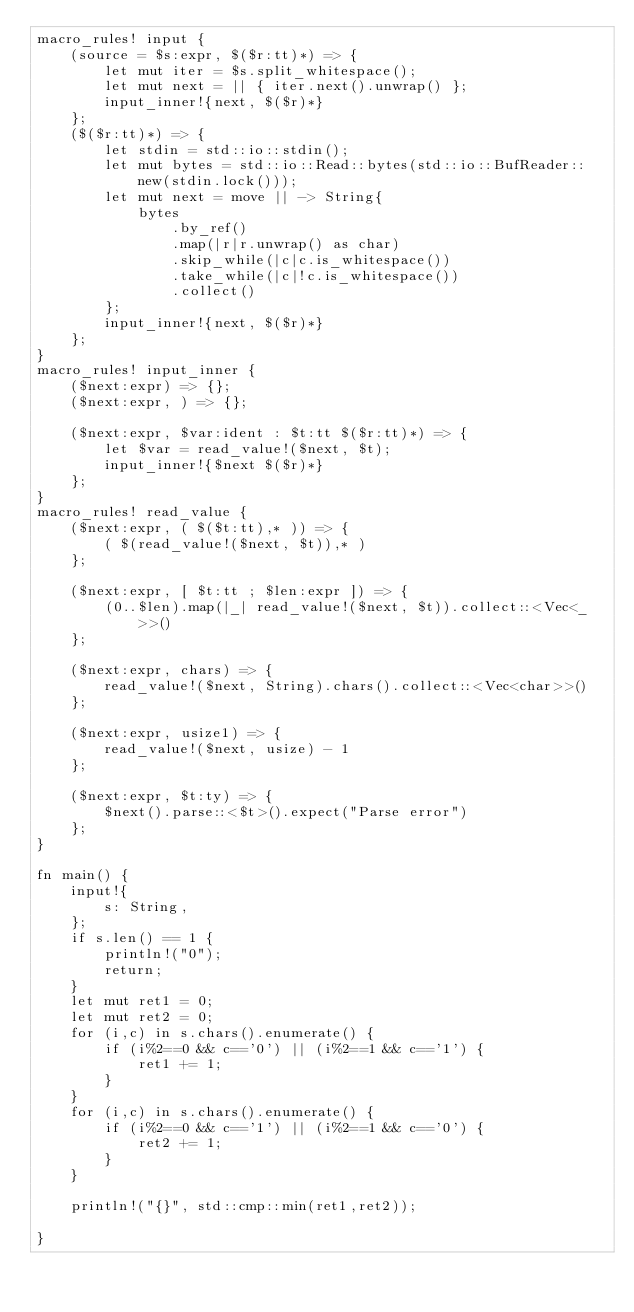Convert code to text. <code><loc_0><loc_0><loc_500><loc_500><_Rust_>macro_rules! input {
    (source = $s:expr, $($r:tt)*) => {
        let mut iter = $s.split_whitespace();
        let mut next = || { iter.next().unwrap() };
        input_inner!{next, $($r)*}
    };
    ($($r:tt)*) => {
        let stdin = std::io::stdin();
        let mut bytes = std::io::Read::bytes(std::io::BufReader::new(stdin.lock()));
        let mut next = move || -> String{
            bytes
                .by_ref()
                .map(|r|r.unwrap() as char)
                .skip_while(|c|c.is_whitespace())
                .take_while(|c|!c.is_whitespace())
                .collect()
        };
        input_inner!{next, $($r)*}
    };
}
macro_rules! input_inner {
    ($next:expr) => {};
    ($next:expr, ) => {};

    ($next:expr, $var:ident : $t:tt $($r:tt)*) => {
        let $var = read_value!($next, $t);
        input_inner!{$next $($r)*}
    };
}
macro_rules! read_value {
    ($next:expr, ( $($t:tt),* )) => {
        ( $(read_value!($next, $t)),* )
    };

    ($next:expr, [ $t:tt ; $len:expr ]) => {
        (0..$len).map(|_| read_value!($next, $t)).collect::<Vec<_>>()
    };

    ($next:expr, chars) => {
        read_value!($next, String).chars().collect::<Vec<char>>()
    };

    ($next:expr, usize1) => {
        read_value!($next, usize) - 1
    };

    ($next:expr, $t:ty) => {
        $next().parse::<$t>().expect("Parse error")
    };
}

fn main() {
    input!{
        s: String,
    };
    if s.len() == 1 {
        println!("0");
        return;
    }
    let mut ret1 = 0;
    let mut ret2 = 0;
    for (i,c) in s.chars().enumerate() {
        if (i%2==0 && c=='0') || (i%2==1 && c=='1') {
            ret1 += 1;
        }
    }
    for (i,c) in s.chars().enumerate() {
        if (i%2==0 && c=='1') || (i%2==1 && c=='0') {
            ret2 += 1;
        }
    }

    println!("{}", std::cmp::min(ret1,ret2));

}

</code> 